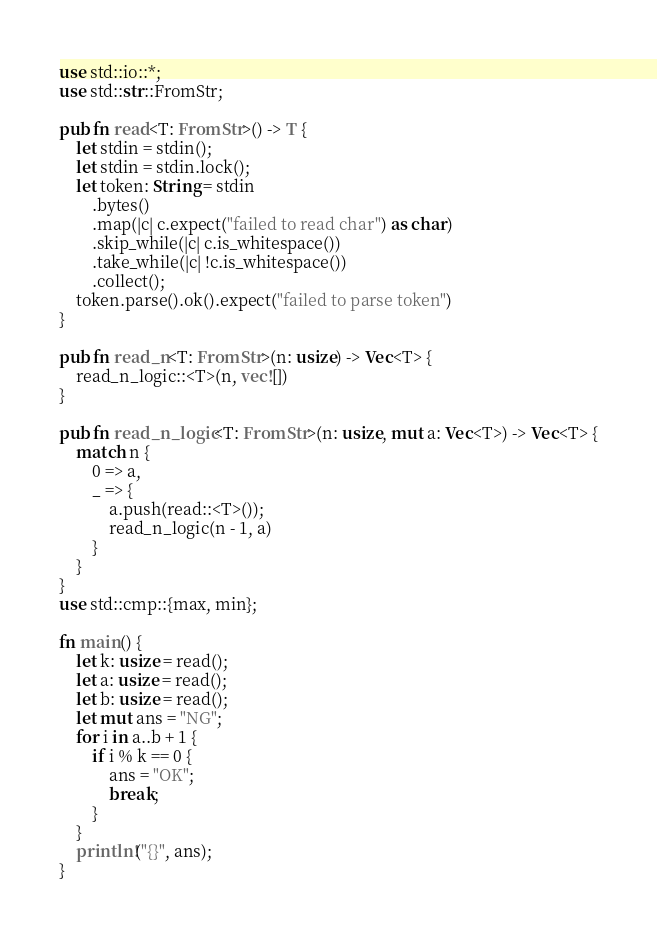Convert code to text. <code><loc_0><loc_0><loc_500><loc_500><_Rust_>use std::io::*;
use std::str::FromStr;

pub fn read<T: FromStr>() -> T {
    let stdin = stdin();
    let stdin = stdin.lock();
    let token: String = stdin
        .bytes()
        .map(|c| c.expect("failed to read char") as char)
        .skip_while(|c| c.is_whitespace())
        .take_while(|c| !c.is_whitespace())
        .collect();
    token.parse().ok().expect("failed to parse token")
}

pub fn read_n<T: FromStr>(n: usize) -> Vec<T> {
    read_n_logic::<T>(n, vec![])
}

pub fn read_n_logic<T: FromStr>(n: usize, mut a: Vec<T>) -> Vec<T> {
    match n {
        0 => a,
        _ => {
            a.push(read::<T>());
            read_n_logic(n - 1, a)
        }
    }
}
use std::cmp::{max, min};

fn main() {
    let k: usize = read();
    let a: usize = read();
    let b: usize = read();
    let mut ans = "NG";
    for i in a..b + 1 {
        if i % k == 0 {
            ans = "OK";
            break;
        }
    }
    println!("{}", ans);
}
</code> 